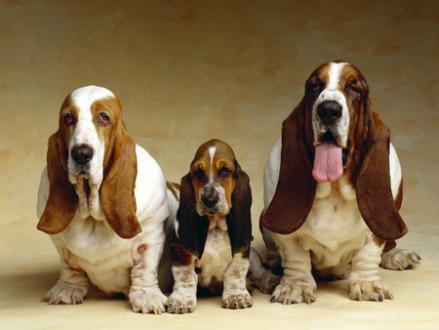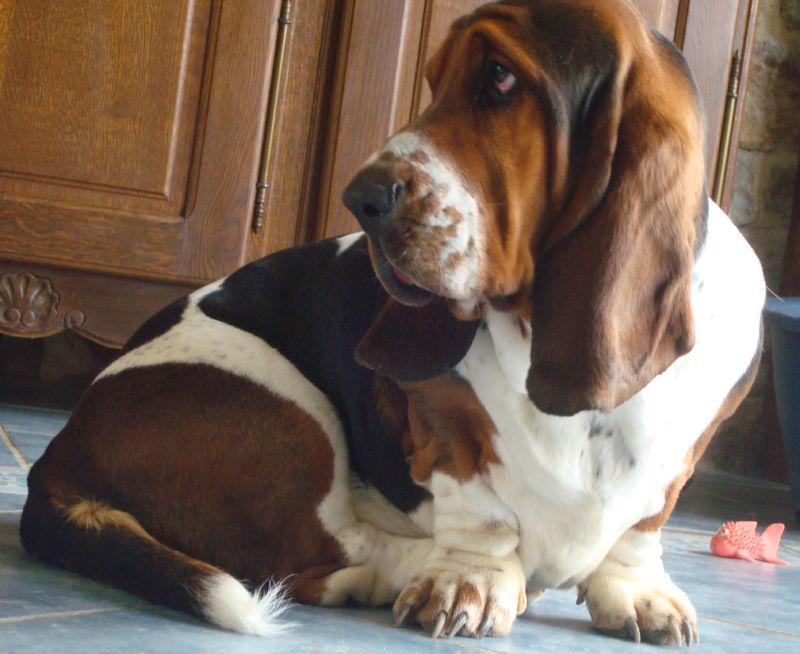The first image is the image on the left, the second image is the image on the right. For the images displayed, is the sentence "There are more basset hounds in the right image than in the left." factually correct? Answer yes or no. No. The first image is the image on the left, the second image is the image on the right. For the images displayed, is the sentence "There is one dog in the left image" factually correct? Answer yes or no. No. 